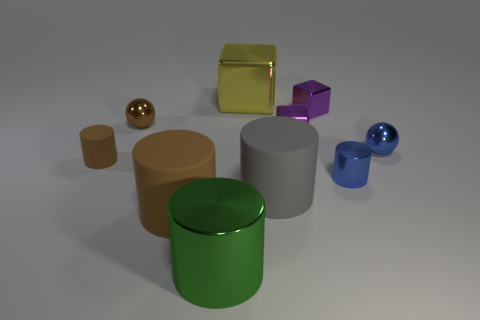Are there more blue shiny spheres that are behind the large gray cylinder than big yellow cubes that are on the left side of the yellow thing? After carefully examining the image, it appears that there are two blue shiny spheres located behind the large gray cylinder. In contrast, there is only one big yellow cube placed on the left side of the large golden cube. Therefore, the correct answer is that there are indeed more blue shiny spheres behind the large gray cylinder than big yellow cubes on the left side of the gold cube. 